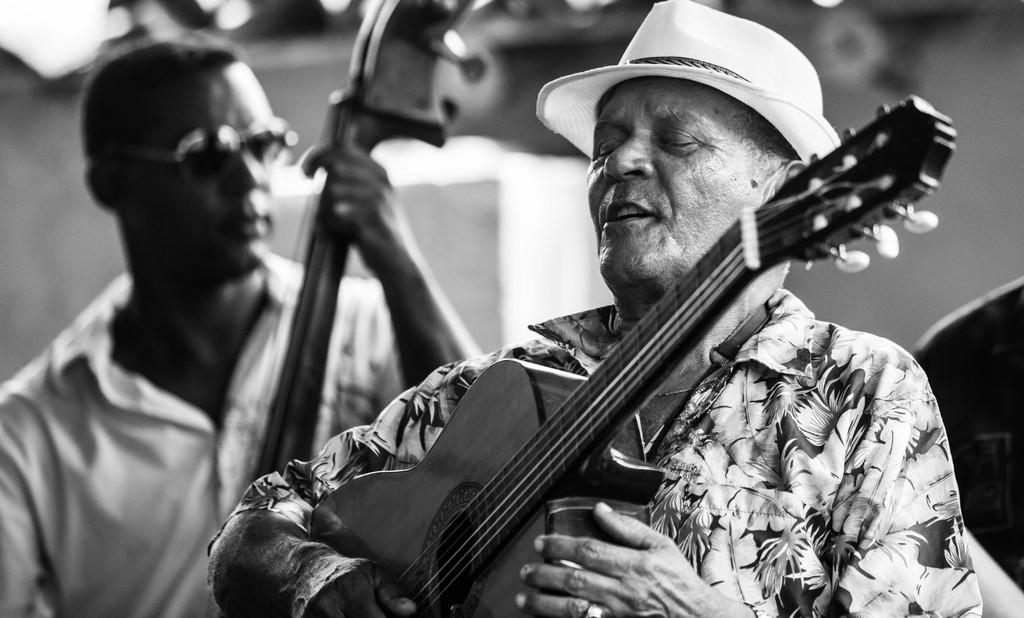How many people are in the image? There are two persons in the image. What are the persons doing in the image? Both persons are playing guitar. Can you describe any accessories worn by the persons? One person is wearing a cap, and one person has goggles. What is the color scheme of the image? The image is black and white. What type of star can be seen in the image? There is no star visible in the image; it is a black and white image of two persons playing guitar. Can you tell me where the church is located in the image? There is no church present in the image. 